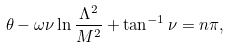Convert formula to latex. <formula><loc_0><loc_0><loc_500><loc_500>\theta - \omega \nu \ln \frac { \Lambda ^ { 2 } } { M ^ { 2 } } + \tan ^ { - 1 } \nu = n \pi ,</formula> 